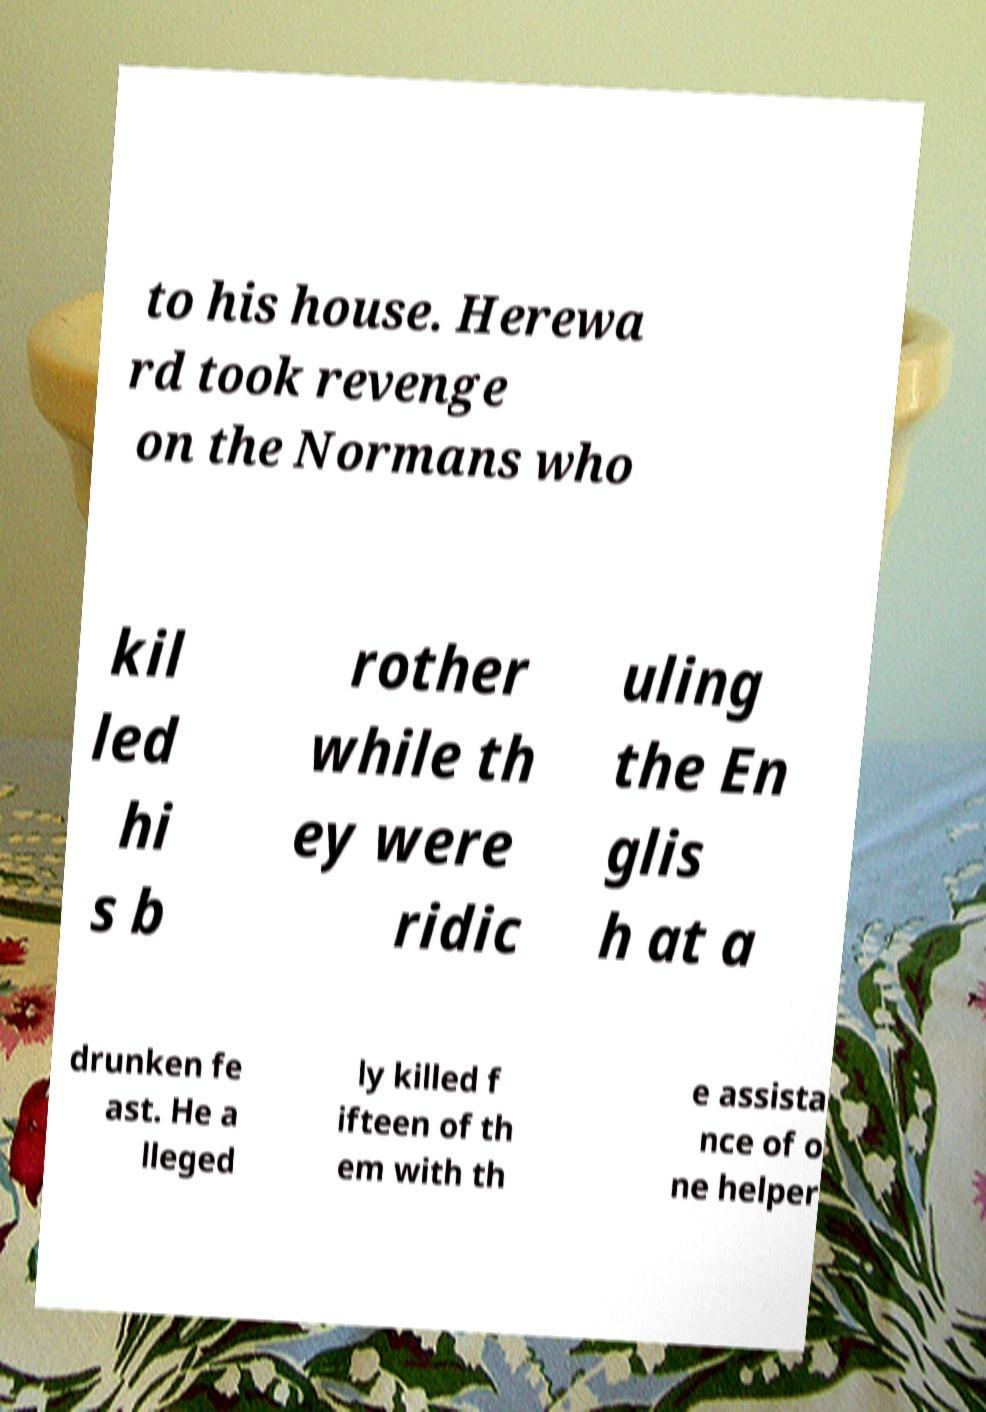I need the written content from this picture converted into text. Can you do that? to his house. Herewa rd took revenge on the Normans who kil led hi s b rother while th ey were ridic uling the En glis h at a drunken fe ast. He a lleged ly killed f ifteen of th em with th e assista nce of o ne helper 